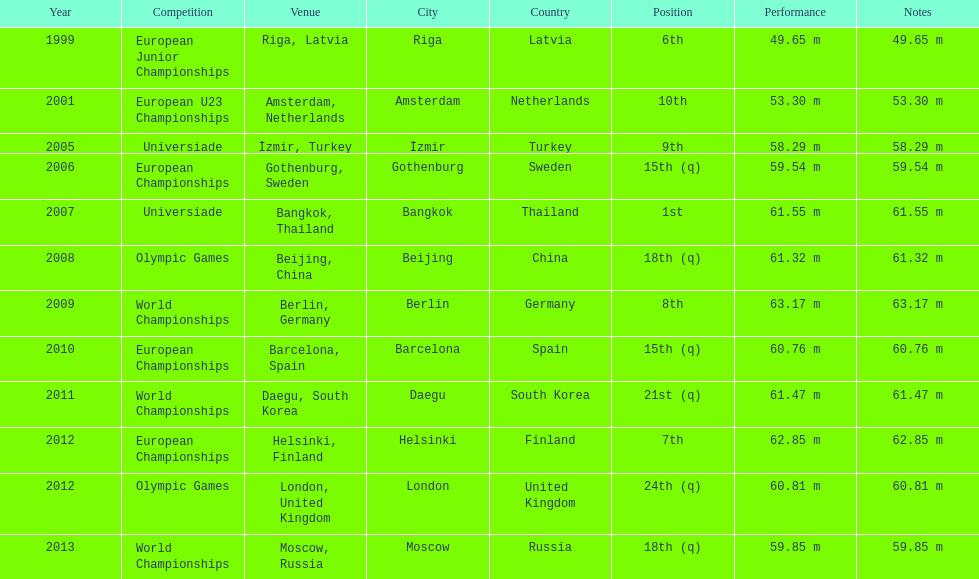What are the total number of times european junior championships is listed as the competition? 1. 